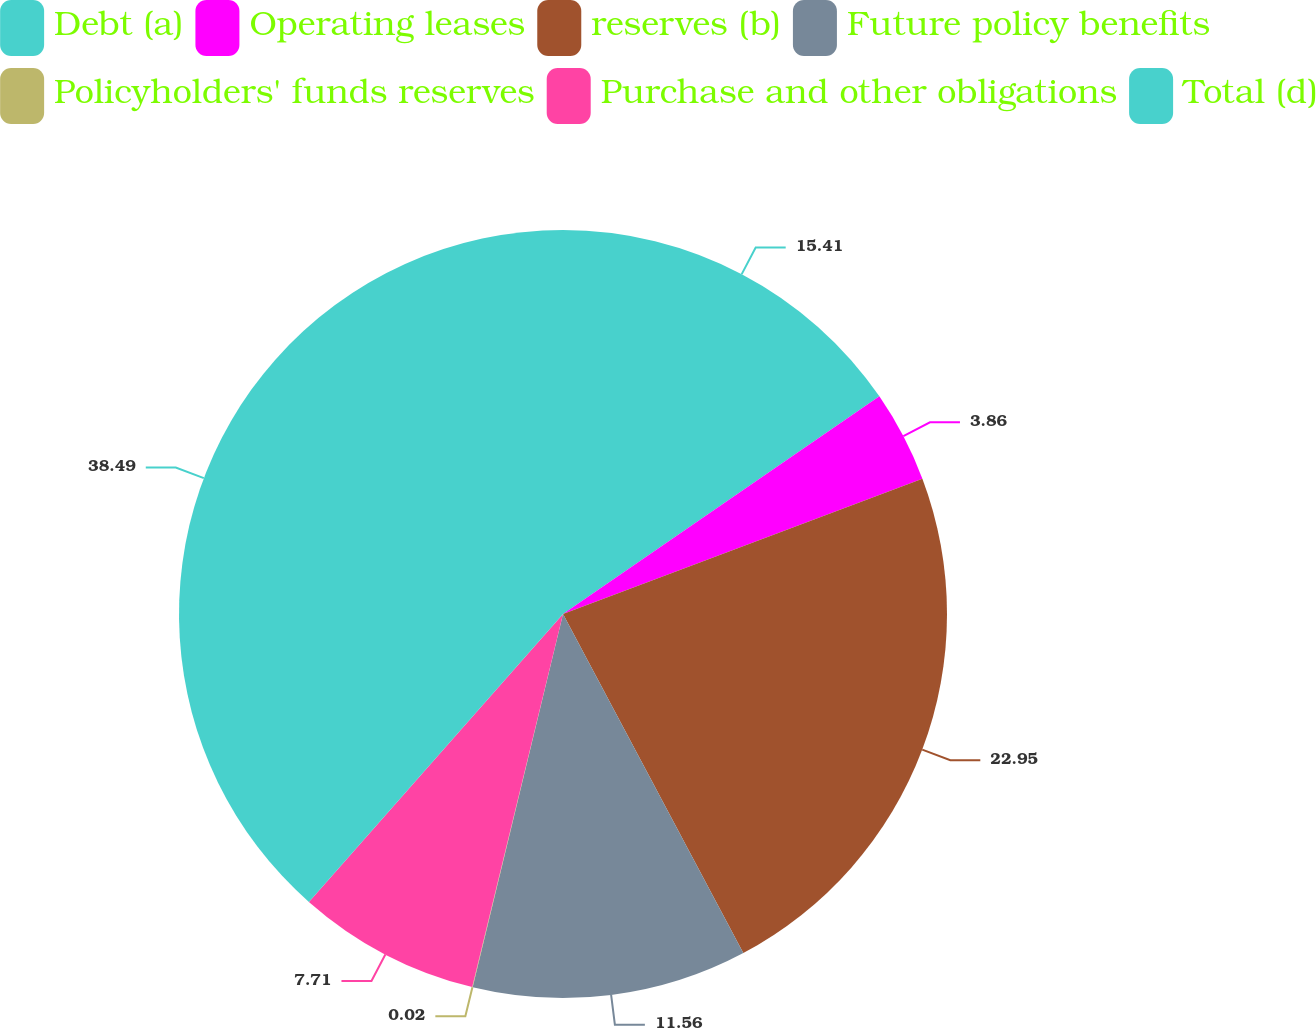Convert chart. <chart><loc_0><loc_0><loc_500><loc_500><pie_chart><fcel>Debt (a)<fcel>Operating leases<fcel>reserves (b)<fcel>Future policy benefits<fcel>Policyholders' funds reserves<fcel>Purchase and other obligations<fcel>Total (d)<nl><fcel>15.41%<fcel>3.86%<fcel>22.95%<fcel>11.56%<fcel>0.02%<fcel>7.71%<fcel>38.49%<nl></chart> 